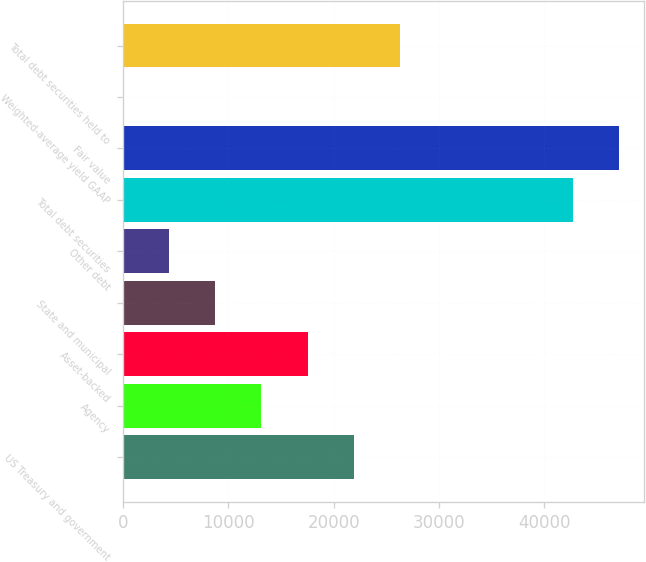<chart> <loc_0><loc_0><loc_500><loc_500><bar_chart><fcel>US Treasury and government<fcel>Agency<fcel>Asset-backed<fcel>State and municipal<fcel>Other debt<fcel>Total debt securities<fcel>Fair value<fcel>Weighted-average yield GAAP<fcel>Total debt securities held to<nl><fcel>21898.5<fcel>13140.2<fcel>17519.3<fcel>8761.09<fcel>4381.97<fcel>42739<fcel>47118.1<fcel>2.85<fcel>26277.6<nl></chart> 